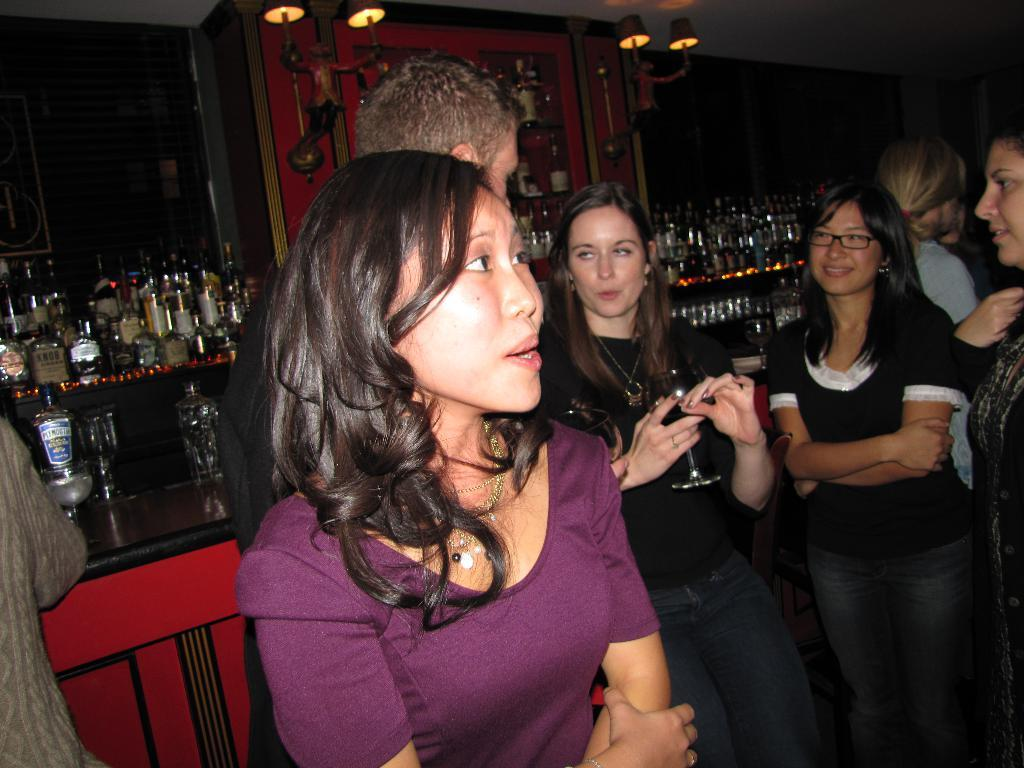What is the main subject of the image? The main subject of the image is a group of people. How can you describe the attire of the people in the image? The people are wearing different color dresses. What can be seen in the background of the image? There are wine bottles and glasses in the background of the image. What is visible at the top of the image? There are lights visible at the top of the image. What type of mint is growing near the wine bottles in the image? There is no mint visible in the image; it only features wine bottles and glasses in the background. 